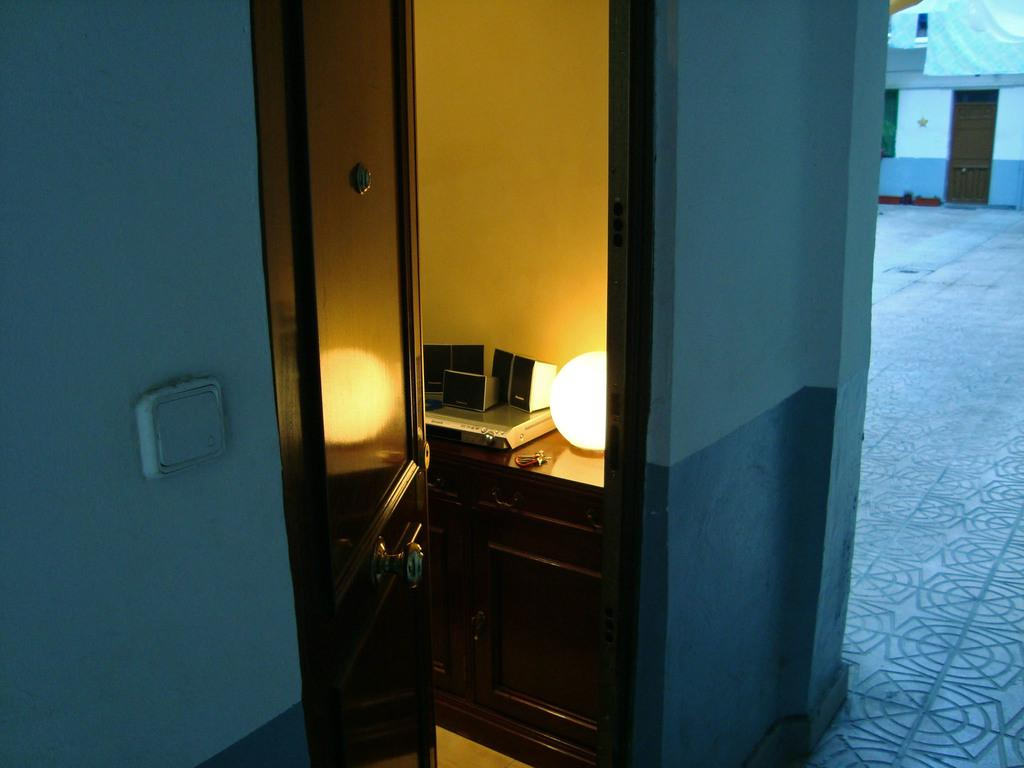What type of space is depicted in the image? There is a room in the image. What can be seen in the room that provides illumination? There is a light in the room. What type of entertainment device is present in the room? There is a DVD player with speakers in the room. Where are the DVD player and speakers located in the room? The DVD player and speakers are on a cupboard. What type of door is present in the room? There is a wooden door in the room. What can be seen outside the room on the right side of the image? There is a house visible on the right side of the image. What type of stamp can be seen on the DVD player in the image? There is no stamp present on the DVD player in the image. What type of straw is used to decorate the room in the image? There is no straw present in the room or used for decoration in the image. 